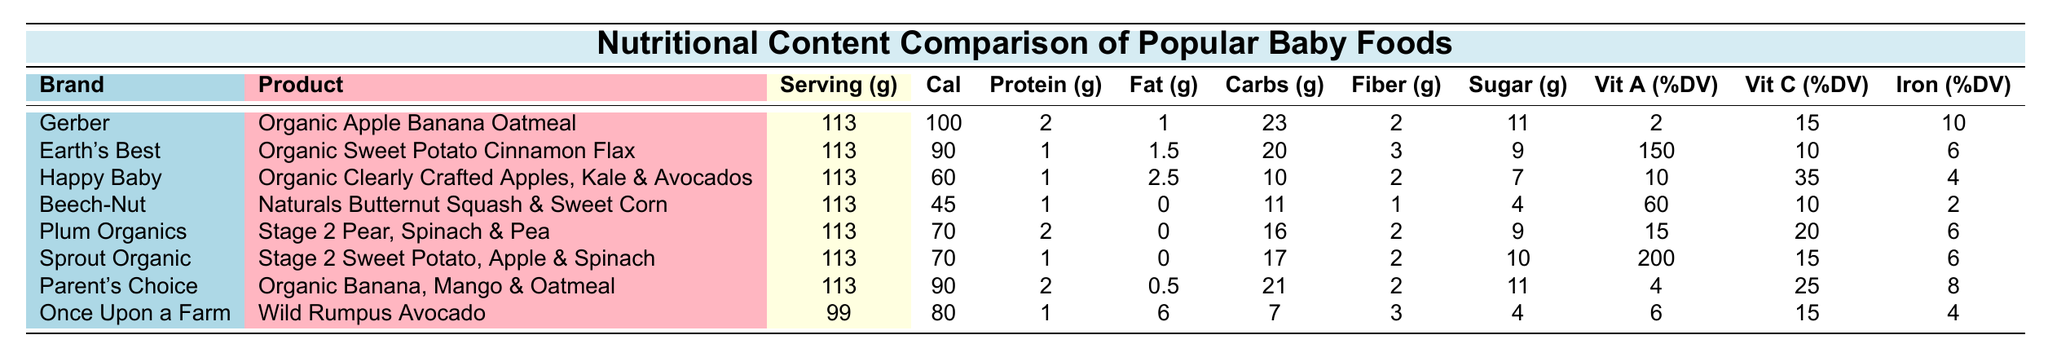What is the calorie content of Gerber's Organic Apple Banana Oatmeal? The calorie content for Gerber's Organic Apple Banana Oatmeal is listed in the table as 100 calories.
Answer: 100 calories Which baby food has the highest vitamin A percentage? The table shows that Earth's Best Organic Sweet Potato Cinnamon Flax has the highest vitamin A percentage with 150% DV.
Answer: 150% DV What is the total protein content of Happy Baby's Organic Clearly Crafted Apples, Kale & Avocados? The protein content for Happy Baby's product is stated as 1 gram in the table.
Answer: 1 gram How many grams of sugar are in Plum Organics Stage 2 Pear, Spinach & Pea? According to the table, the sugar content for Plum Organics is 9 grams.
Answer: 9 grams Calculate the average calories of the listed baby foods. There are eight products listed: 100, 90, 60, 45, 70, 70, 90, and 80 calories. The sum is (100 + 90 + 60 + 45 + 70 + 70 + 90 + 80) = 605. Dividing by 8 gives an average of 605 / 8 = 75.625, which rounds to approximately 76 calories.
Answer: 76 calories Is Beech-Nut Naturals Butternut Squash & Sweet Corn higher in carbohydrates than Happy Baby's product? Beech-Nut has 11 grams of carbohydrates, while Happy Baby has 10 grams. Thus, Beech-Nut is higher.
Answer: Yes How much more fiber does Earth's Best provide compared to Beech-Nut? Earth's Best has 3 grams of fiber, while Beech-Nut has 1 gram. The difference is 3 - 1 = 2 grams.
Answer: 2 grams Which product has the lowest amount of calories? Comparing the calorie values in the table, Beech-Nut Naturals Butternut Squash & Sweet Corn has the lowest at 45 calories.
Answer: 45 calories What is the total amount of fat in Parent's Choice Organic Banana, Mango & Oatmeal? The table specifies the total fat for Parent's Choice as 0.5 grams.
Answer: 0.5 grams If you combine the iron content of Sprout Organic Stage 2 Sweet Potato, Apple & Spinach and Once Upon A Farm Wild Rumpus Avocado, what would the total be? Sprout Organic has 6% DV for iron and Once Upon A Farm has 4% DV. Adding them gives 6 + 4 = 10% DV for iron.
Answer: 10% DV 